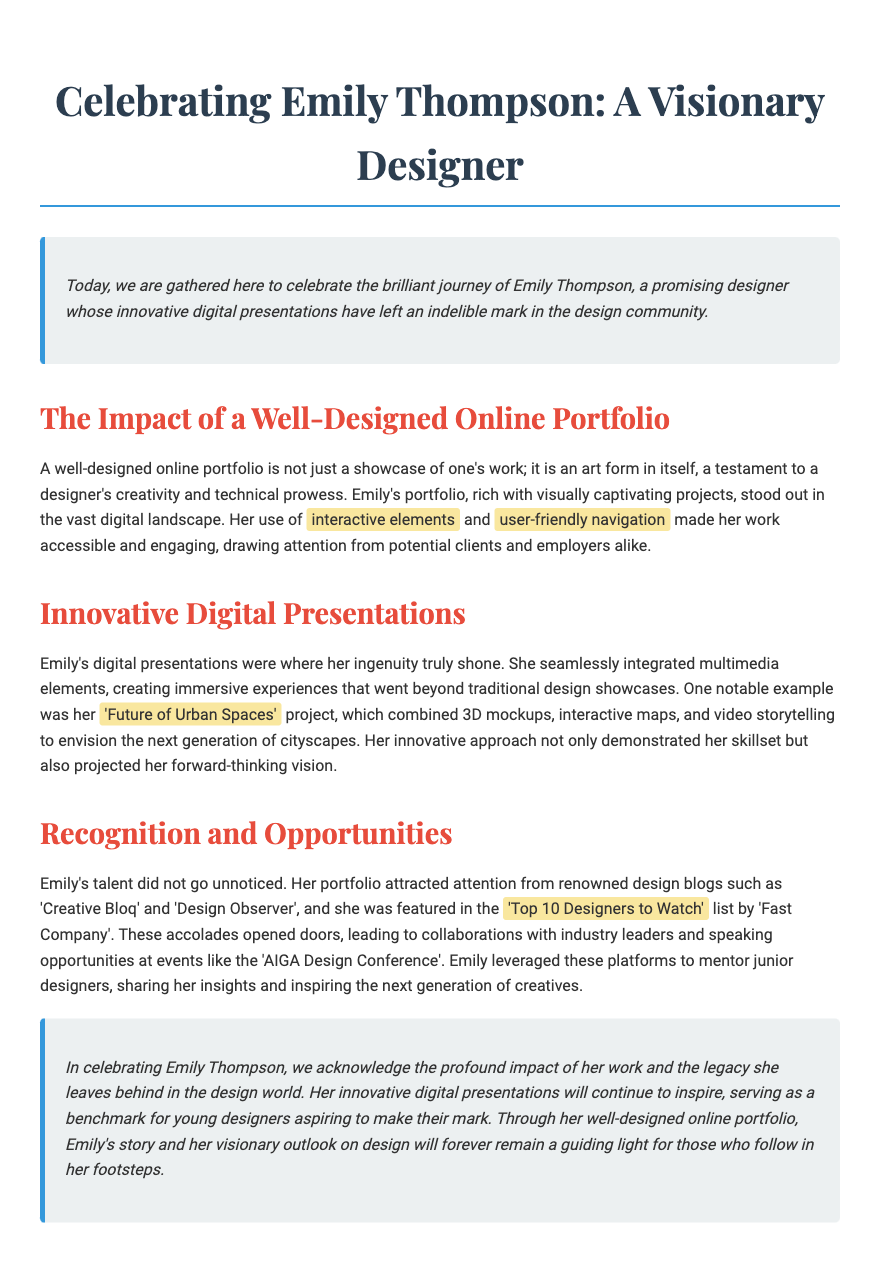What is the name of the designer being celebrated? The name of the designer being celebrated is mentioned in the title of the document.
Answer: Emily Thompson What notable design project is highlighted in the document? The document specifically mentions a project that showcases Emily's skills and creativity.
Answer: Future of Urban Spaces Which design blogs featured Emily's work? The document lists specific design blogs that recognized Emily's talent.
Answer: Creative Bloq and Design Observer Who created the 'Top 10 Designers to Watch' list? The document identifies the organization responsible for this recognition.
Answer: Fast Company What elements made Emily’s portfolio engaging? The document mentions specific features that enhanced the appeal of Emily's portfolio.
Answer: Interactive elements and user-friendly navigation What conference did Emily speak at? The document highlights a specific event where Emily had speaking opportunities.
Answer: AIGA Design Conference What was the impact of Emily's online portfolio? The document states the significance of her portfolio in the design community.
Answer: A benchmark for young designers How did Emily contribute to the design community? The document describes a specific way in which she helped others in the field.
Answer: Mentoring junior designers 